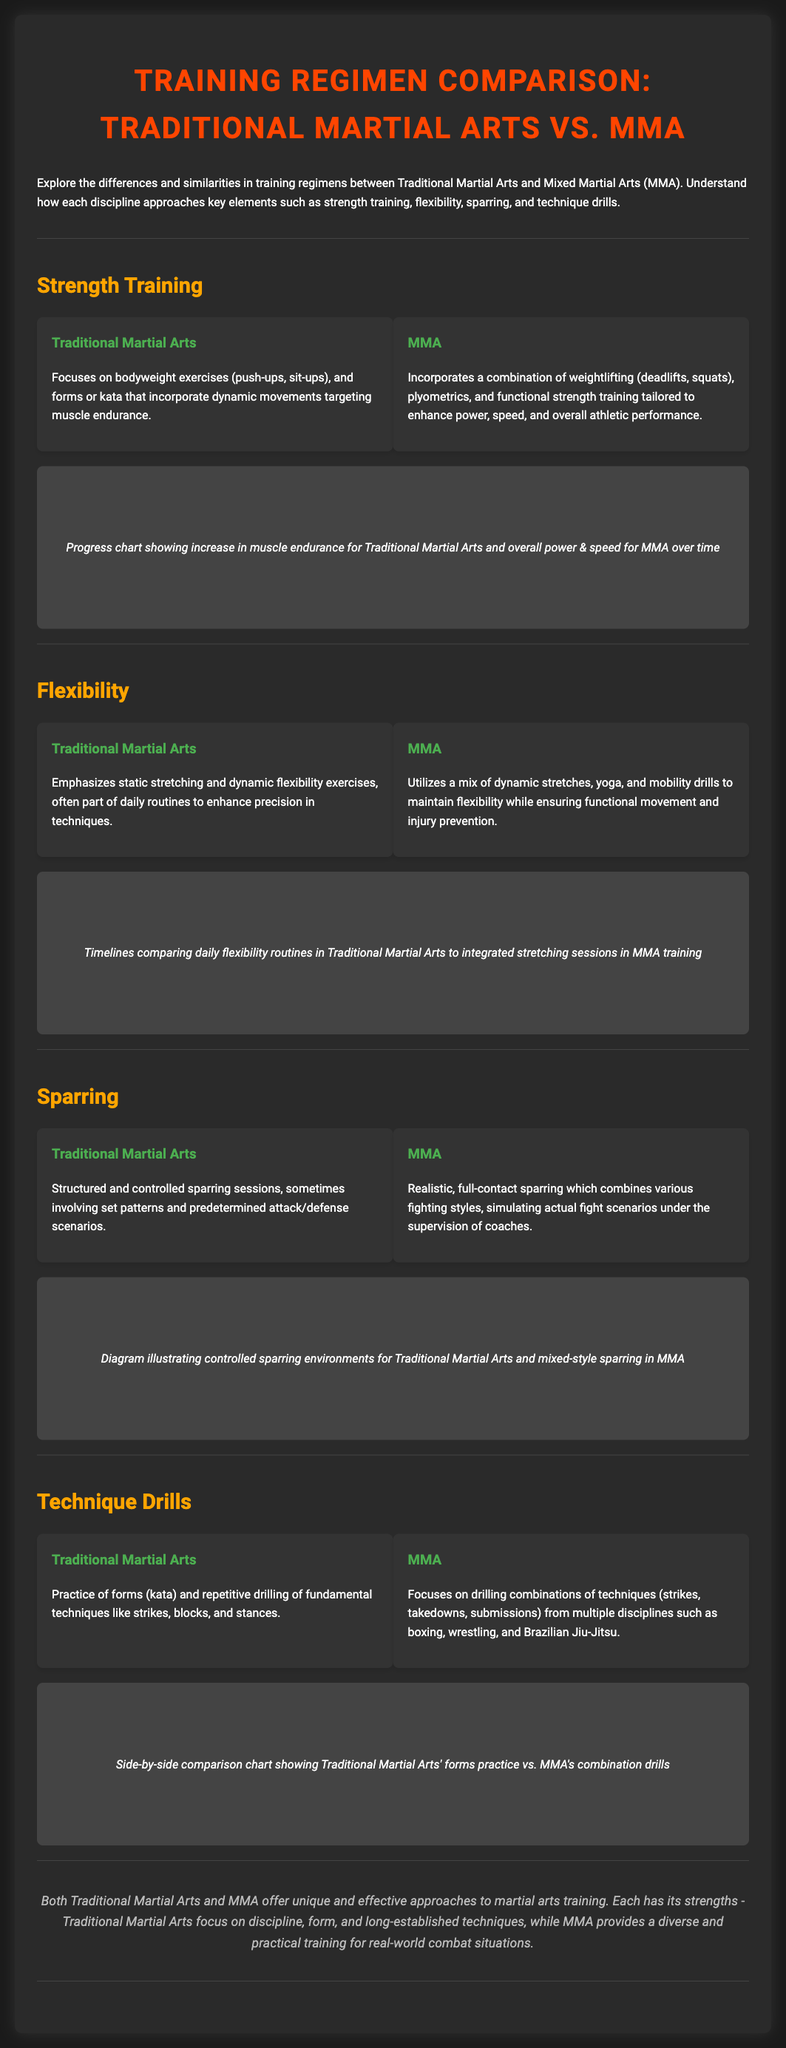What type of strength training does Traditional Martial Arts focus on? Traditional Martial Arts focuses on bodyweight exercises and forms or kata that incorporate dynamic movements targeting muscle endurance.
Answer: Bodyweight exercises What kind of sparring is emphasized in MMA? MMA emphasizes realistic, full-contact sparring which combines various fighting styles.
Answer: Full-contact sparring What is a primary difference in flexibility training between Traditional Martial Arts and MMA? Traditional Martial Arts emphasizes static stretching, while MMA utilizes dynamic stretches and mobility drills.
Answer: Static vs. dynamic stretching Which technique practice is used in Traditional Martial Arts? Traditional Martial Arts involves the practice of forms (kata) and repetitive drilling of fundamental techniques.
Answer: Forms (kata) What unique elements are included in MMA's training regimen? MMA incorporates weightlifting, plyometrics, and functional strength training tailored for performance.
Answer: Weightlifting, plyometrics How do flexibility routines in Traditional Martial Arts compare to those in MMA? Traditional Martial Arts has daily routines, while MMA integrates stretching sessions.
Answer: Daily vs. integrated sessions What is the main focus of technique drills in MMA? MMA focuses on drilling combinations of techniques from multiple disciplines like boxing and wrestling.
Answer: Combinations of techniques What element does Traditional Martial Arts training emphasize more than MMA? Traditional Martial Arts emphasizes discipline and long-established techniques.
Answer: Discipline In the visual section, what is represented related to strength training progress? The visual section shows a progress chart comparing increases in muscle endurance for Traditional Martial Arts and overall power and speed for MMA.
Answer: Progress chart 